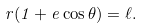<formula> <loc_0><loc_0><loc_500><loc_500>r ( 1 + e \cos \theta ) = \ell .</formula> 